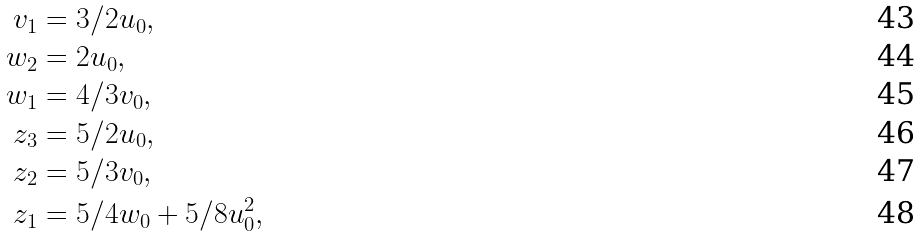Convert formula to latex. <formula><loc_0><loc_0><loc_500><loc_500>v _ { 1 } & = 3 / 2 u _ { 0 } , \\ w _ { 2 } & = 2 u _ { 0 } , \\ w _ { 1 } & = 4 / 3 v _ { 0 } , \\ z _ { 3 } & = 5 / 2 u _ { 0 } , \\ z _ { 2 } & = 5 / 3 v _ { 0 } , \\ z _ { 1 } & = 5 / 4 w _ { 0 } + 5 / 8 u _ { 0 } ^ { 2 } ,</formula> 